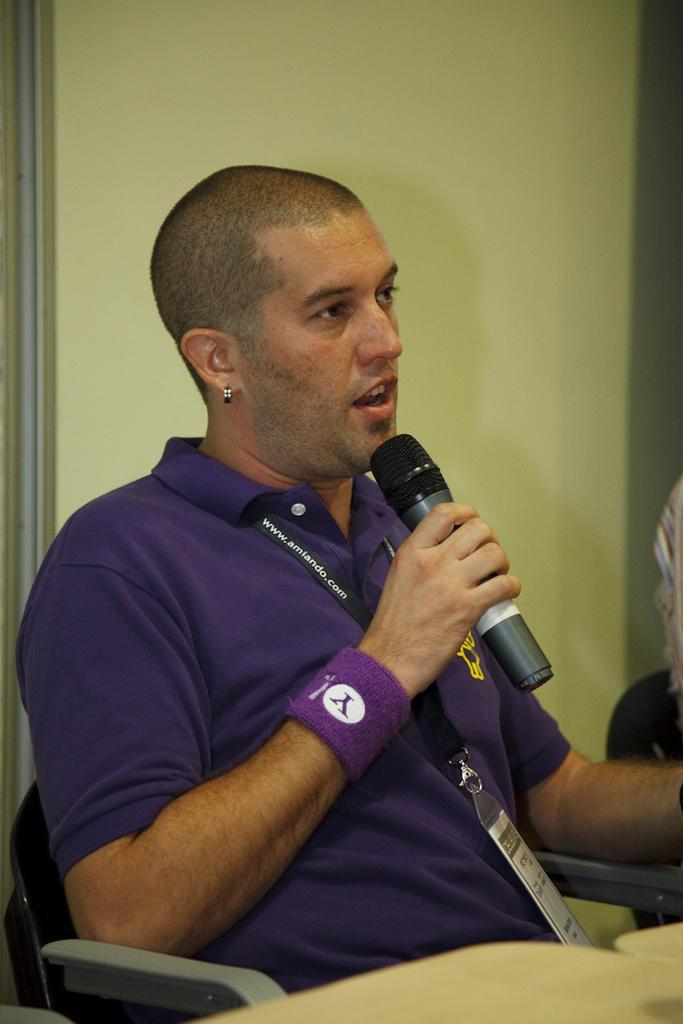In one or two sentences, can you explain what this image depicts? In this picture we can see a person sitting on a chair, he is holding a mic and we can see a wall in the background. 